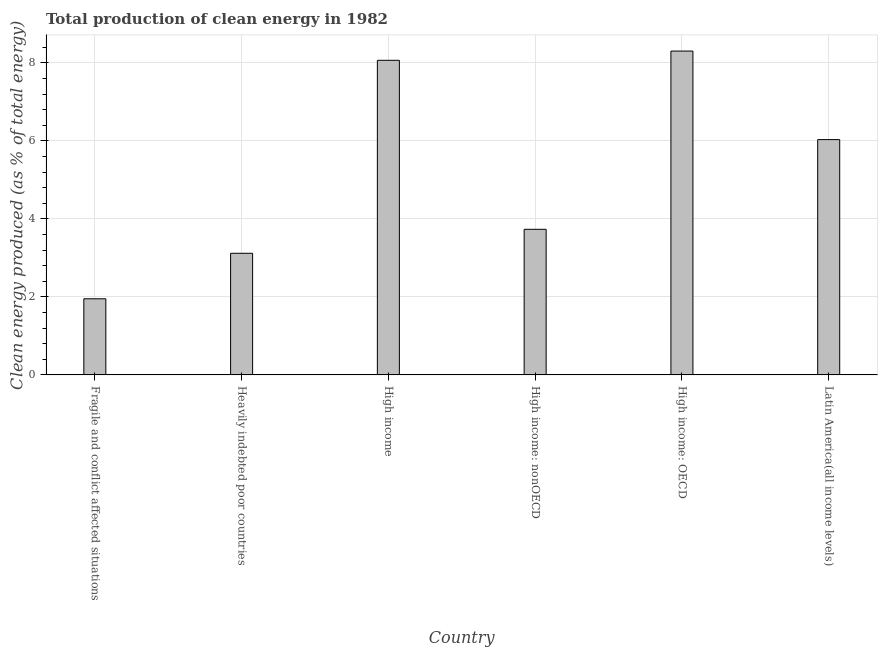Does the graph contain grids?
Provide a short and direct response. Yes. What is the title of the graph?
Keep it short and to the point. Total production of clean energy in 1982. What is the label or title of the Y-axis?
Your answer should be very brief. Clean energy produced (as % of total energy). What is the production of clean energy in Heavily indebted poor countries?
Give a very brief answer. 3.12. Across all countries, what is the maximum production of clean energy?
Ensure brevity in your answer.  8.3. Across all countries, what is the minimum production of clean energy?
Provide a short and direct response. 1.95. In which country was the production of clean energy maximum?
Your answer should be compact. High income: OECD. In which country was the production of clean energy minimum?
Your answer should be compact. Fragile and conflict affected situations. What is the sum of the production of clean energy?
Give a very brief answer. 31.21. What is the difference between the production of clean energy in Fragile and conflict affected situations and High income?
Offer a very short reply. -6.12. What is the average production of clean energy per country?
Your response must be concise. 5.2. What is the median production of clean energy?
Ensure brevity in your answer.  4.88. What is the ratio of the production of clean energy in Heavily indebted poor countries to that in High income?
Your response must be concise. 0.39. Is the production of clean energy in Fragile and conflict affected situations less than that in Latin America(all income levels)?
Keep it short and to the point. Yes. What is the difference between the highest and the second highest production of clean energy?
Keep it short and to the point. 0.24. Is the sum of the production of clean energy in Heavily indebted poor countries and Latin America(all income levels) greater than the maximum production of clean energy across all countries?
Make the answer very short. Yes. What is the difference between the highest and the lowest production of clean energy?
Offer a terse response. 6.35. How many bars are there?
Your response must be concise. 6. Are all the bars in the graph horizontal?
Keep it short and to the point. No. What is the Clean energy produced (as % of total energy) of Fragile and conflict affected situations?
Your response must be concise. 1.95. What is the Clean energy produced (as % of total energy) in Heavily indebted poor countries?
Ensure brevity in your answer.  3.12. What is the Clean energy produced (as % of total energy) in High income?
Keep it short and to the point. 8.07. What is the Clean energy produced (as % of total energy) in High income: nonOECD?
Give a very brief answer. 3.73. What is the Clean energy produced (as % of total energy) of High income: OECD?
Offer a terse response. 8.3. What is the Clean energy produced (as % of total energy) of Latin America(all income levels)?
Provide a short and direct response. 6.03. What is the difference between the Clean energy produced (as % of total energy) in Fragile and conflict affected situations and Heavily indebted poor countries?
Your response must be concise. -1.17. What is the difference between the Clean energy produced (as % of total energy) in Fragile and conflict affected situations and High income?
Keep it short and to the point. -6.12. What is the difference between the Clean energy produced (as % of total energy) in Fragile and conflict affected situations and High income: nonOECD?
Provide a succinct answer. -1.78. What is the difference between the Clean energy produced (as % of total energy) in Fragile and conflict affected situations and High income: OECD?
Offer a terse response. -6.35. What is the difference between the Clean energy produced (as % of total energy) in Fragile and conflict affected situations and Latin America(all income levels)?
Make the answer very short. -4.08. What is the difference between the Clean energy produced (as % of total energy) in Heavily indebted poor countries and High income?
Keep it short and to the point. -4.95. What is the difference between the Clean energy produced (as % of total energy) in Heavily indebted poor countries and High income: nonOECD?
Provide a succinct answer. -0.62. What is the difference between the Clean energy produced (as % of total energy) in Heavily indebted poor countries and High income: OECD?
Your answer should be very brief. -5.19. What is the difference between the Clean energy produced (as % of total energy) in Heavily indebted poor countries and Latin America(all income levels)?
Your response must be concise. -2.92. What is the difference between the Clean energy produced (as % of total energy) in High income and High income: nonOECD?
Your response must be concise. 4.33. What is the difference between the Clean energy produced (as % of total energy) in High income and High income: OECD?
Your answer should be very brief. -0.24. What is the difference between the Clean energy produced (as % of total energy) in High income and Latin America(all income levels)?
Your answer should be very brief. 2.03. What is the difference between the Clean energy produced (as % of total energy) in High income: nonOECD and High income: OECD?
Give a very brief answer. -4.57. What is the difference between the Clean energy produced (as % of total energy) in High income: nonOECD and Latin America(all income levels)?
Make the answer very short. -2.3. What is the difference between the Clean energy produced (as % of total energy) in High income: OECD and Latin America(all income levels)?
Your response must be concise. 2.27. What is the ratio of the Clean energy produced (as % of total energy) in Fragile and conflict affected situations to that in Heavily indebted poor countries?
Offer a very short reply. 0.63. What is the ratio of the Clean energy produced (as % of total energy) in Fragile and conflict affected situations to that in High income?
Keep it short and to the point. 0.24. What is the ratio of the Clean energy produced (as % of total energy) in Fragile and conflict affected situations to that in High income: nonOECD?
Your answer should be compact. 0.52. What is the ratio of the Clean energy produced (as % of total energy) in Fragile and conflict affected situations to that in High income: OECD?
Ensure brevity in your answer.  0.23. What is the ratio of the Clean energy produced (as % of total energy) in Fragile and conflict affected situations to that in Latin America(all income levels)?
Keep it short and to the point. 0.32. What is the ratio of the Clean energy produced (as % of total energy) in Heavily indebted poor countries to that in High income?
Offer a very short reply. 0.39. What is the ratio of the Clean energy produced (as % of total energy) in Heavily indebted poor countries to that in High income: nonOECD?
Keep it short and to the point. 0.83. What is the ratio of the Clean energy produced (as % of total energy) in Heavily indebted poor countries to that in High income: OECD?
Your answer should be very brief. 0.38. What is the ratio of the Clean energy produced (as % of total energy) in Heavily indebted poor countries to that in Latin America(all income levels)?
Keep it short and to the point. 0.52. What is the ratio of the Clean energy produced (as % of total energy) in High income to that in High income: nonOECD?
Offer a very short reply. 2.16. What is the ratio of the Clean energy produced (as % of total energy) in High income to that in Latin America(all income levels)?
Ensure brevity in your answer.  1.34. What is the ratio of the Clean energy produced (as % of total energy) in High income: nonOECD to that in High income: OECD?
Make the answer very short. 0.45. What is the ratio of the Clean energy produced (as % of total energy) in High income: nonOECD to that in Latin America(all income levels)?
Your response must be concise. 0.62. What is the ratio of the Clean energy produced (as % of total energy) in High income: OECD to that in Latin America(all income levels)?
Make the answer very short. 1.38. 